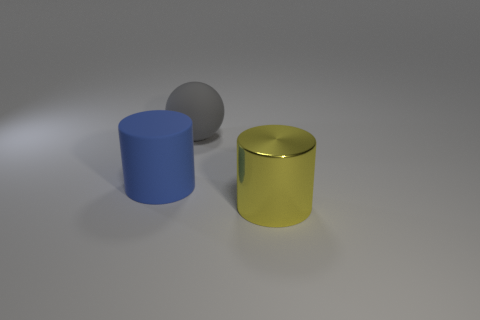What material is the object that is both on the right side of the large matte cylinder and in front of the gray matte thing?
Keep it short and to the point. Metal. There is a cylinder that is left of the big cylinder that is right of the gray matte sphere; is there a big blue rubber object to the left of it?
Provide a succinct answer. No. Are there any other things that have the same material as the big ball?
Provide a short and direct response. Yes. What shape is the blue thing that is the same material as the ball?
Your response must be concise. Cylinder. Is the number of blue objects behind the large sphere less than the number of large blue cylinders on the left side of the large shiny cylinder?
Your answer should be compact. Yes. What number of small objects are matte blocks or gray rubber objects?
Your answer should be very brief. 0. There is a large object that is in front of the large blue thing; is it the same shape as the rubber object behind the big blue cylinder?
Provide a short and direct response. No. There is a cylinder that is behind the cylinder that is right of the matte thing that is in front of the gray rubber object; how big is it?
Offer a very short reply. Large. There is a cylinder behind the yellow metallic cylinder; what size is it?
Your response must be concise. Large. What is the big object that is behind the blue object made of?
Make the answer very short. Rubber. 